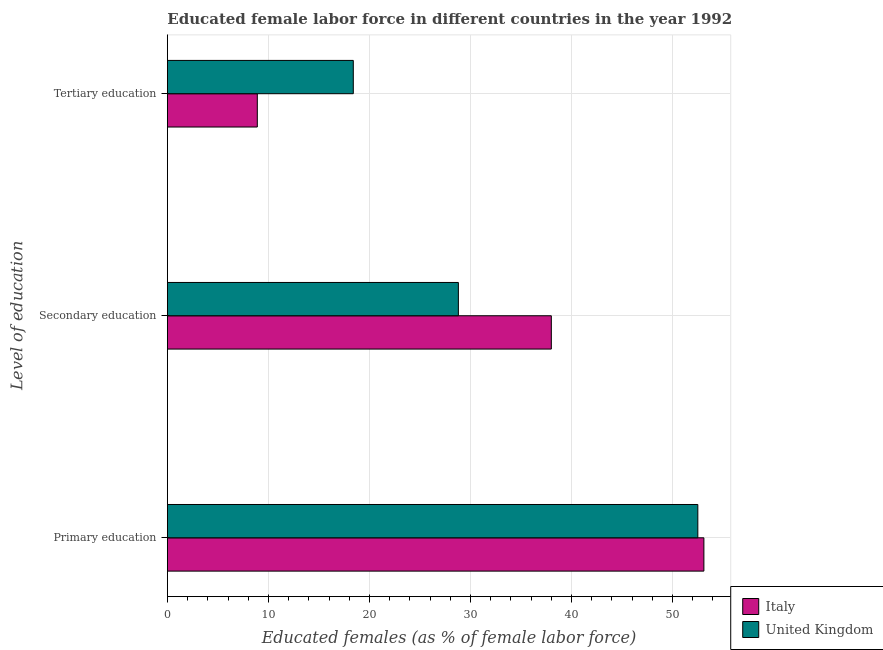How many different coloured bars are there?
Your answer should be compact. 2. How many groups of bars are there?
Provide a short and direct response. 3. Are the number of bars on each tick of the Y-axis equal?
Your answer should be compact. Yes. How many bars are there on the 2nd tick from the top?
Offer a terse response. 2. What is the percentage of female labor force who received secondary education in United Kingdom?
Your response must be concise. 28.8. Across all countries, what is the maximum percentage of female labor force who received primary education?
Offer a very short reply. 53.1. Across all countries, what is the minimum percentage of female labor force who received secondary education?
Your answer should be very brief. 28.8. In which country was the percentage of female labor force who received tertiary education maximum?
Provide a succinct answer. United Kingdom. What is the total percentage of female labor force who received tertiary education in the graph?
Your response must be concise. 27.3. What is the difference between the percentage of female labor force who received tertiary education in United Kingdom and that in Italy?
Provide a succinct answer. 9.5. What is the difference between the percentage of female labor force who received tertiary education in United Kingdom and the percentage of female labor force who received primary education in Italy?
Provide a short and direct response. -34.7. What is the average percentage of female labor force who received tertiary education per country?
Provide a short and direct response. 13.65. What is the difference between the percentage of female labor force who received secondary education and percentage of female labor force who received primary education in Italy?
Provide a succinct answer. -15.1. In how many countries, is the percentage of female labor force who received secondary education greater than 20 %?
Provide a succinct answer. 2. What is the ratio of the percentage of female labor force who received primary education in United Kingdom to that in Italy?
Your response must be concise. 0.99. What is the difference between the highest and the second highest percentage of female labor force who received tertiary education?
Your response must be concise. 9.5. What is the difference between the highest and the lowest percentage of female labor force who received primary education?
Provide a short and direct response. 0.6. What does the 1st bar from the bottom in Secondary education represents?
Your response must be concise. Italy. How many bars are there?
Offer a terse response. 6. Are all the bars in the graph horizontal?
Make the answer very short. Yes. How many countries are there in the graph?
Keep it short and to the point. 2. What is the difference between two consecutive major ticks on the X-axis?
Ensure brevity in your answer.  10. Are the values on the major ticks of X-axis written in scientific E-notation?
Make the answer very short. No. Does the graph contain any zero values?
Provide a succinct answer. No. What is the title of the graph?
Provide a succinct answer. Educated female labor force in different countries in the year 1992. What is the label or title of the X-axis?
Provide a short and direct response. Educated females (as % of female labor force). What is the label or title of the Y-axis?
Ensure brevity in your answer.  Level of education. What is the Educated females (as % of female labor force) of Italy in Primary education?
Keep it short and to the point. 53.1. What is the Educated females (as % of female labor force) in United Kingdom in Primary education?
Offer a very short reply. 52.5. What is the Educated females (as % of female labor force) in Italy in Secondary education?
Your answer should be very brief. 38. What is the Educated females (as % of female labor force) in United Kingdom in Secondary education?
Your answer should be very brief. 28.8. What is the Educated females (as % of female labor force) in Italy in Tertiary education?
Provide a short and direct response. 8.9. What is the Educated females (as % of female labor force) of United Kingdom in Tertiary education?
Your answer should be compact. 18.4. Across all Level of education, what is the maximum Educated females (as % of female labor force) of Italy?
Your answer should be compact. 53.1. Across all Level of education, what is the maximum Educated females (as % of female labor force) of United Kingdom?
Your answer should be compact. 52.5. Across all Level of education, what is the minimum Educated females (as % of female labor force) in Italy?
Provide a succinct answer. 8.9. Across all Level of education, what is the minimum Educated females (as % of female labor force) in United Kingdom?
Offer a very short reply. 18.4. What is the total Educated females (as % of female labor force) in Italy in the graph?
Keep it short and to the point. 100. What is the total Educated females (as % of female labor force) of United Kingdom in the graph?
Your answer should be compact. 99.7. What is the difference between the Educated females (as % of female labor force) of Italy in Primary education and that in Secondary education?
Provide a succinct answer. 15.1. What is the difference between the Educated females (as % of female labor force) in United Kingdom in Primary education and that in Secondary education?
Make the answer very short. 23.7. What is the difference between the Educated females (as % of female labor force) in Italy in Primary education and that in Tertiary education?
Give a very brief answer. 44.2. What is the difference between the Educated females (as % of female labor force) in United Kingdom in Primary education and that in Tertiary education?
Provide a short and direct response. 34.1. What is the difference between the Educated females (as % of female labor force) of Italy in Secondary education and that in Tertiary education?
Your answer should be compact. 29.1. What is the difference between the Educated females (as % of female labor force) in Italy in Primary education and the Educated females (as % of female labor force) in United Kingdom in Secondary education?
Give a very brief answer. 24.3. What is the difference between the Educated females (as % of female labor force) in Italy in Primary education and the Educated females (as % of female labor force) in United Kingdom in Tertiary education?
Your answer should be very brief. 34.7. What is the difference between the Educated females (as % of female labor force) in Italy in Secondary education and the Educated females (as % of female labor force) in United Kingdom in Tertiary education?
Your answer should be very brief. 19.6. What is the average Educated females (as % of female labor force) of Italy per Level of education?
Offer a terse response. 33.33. What is the average Educated females (as % of female labor force) of United Kingdom per Level of education?
Ensure brevity in your answer.  33.23. What is the difference between the Educated females (as % of female labor force) in Italy and Educated females (as % of female labor force) in United Kingdom in Primary education?
Provide a succinct answer. 0.6. What is the difference between the Educated females (as % of female labor force) in Italy and Educated females (as % of female labor force) in United Kingdom in Secondary education?
Give a very brief answer. 9.2. What is the difference between the Educated females (as % of female labor force) in Italy and Educated females (as % of female labor force) in United Kingdom in Tertiary education?
Your answer should be very brief. -9.5. What is the ratio of the Educated females (as % of female labor force) of Italy in Primary education to that in Secondary education?
Provide a short and direct response. 1.4. What is the ratio of the Educated females (as % of female labor force) of United Kingdom in Primary education to that in Secondary education?
Offer a very short reply. 1.82. What is the ratio of the Educated females (as % of female labor force) of Italy in Primary education to that in Tertiary education?
Your answer should be very brief. 5.97. What is the ratio of the Educated females (as % of female labor force) of United Kingdom in Primary education to that in Tertiary education?
Your answer should be compact. 2.85. What is the ratio of the Educated females (as % of female labor force) of Italy in Secondary education to that in Tertiary education?
Provide a short and direct response. 4.27. What is the ratio of the Educated females (as % of female labor force) in United Kingdom in Secondary education to that in Tertiary education?
Your answer should be very brief. 1.57. What is the difference between the highest and the second highest Educated females (as % of female labor force) of Italy?
Ensure brevity in your answer.  15.1. What is the difference between the highest and the second highest Educated females (as % of female labor force) of United Kingdom?
Provide a succinct answer. 23.7. What is the difference between the highest and the lowest Educated females (as % of female labor force) in Italy?
Your answer should be compact. 44.2. What is the difference between the highest and the lowest Educated females (as % of female labor force) in United Kingdom?
Make the answer very short. 34.1. 